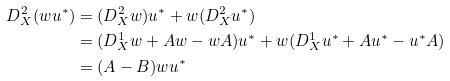Convert formula to latex. <formula><loc_0><loc_0><loc_500><loc_500>D _ { X } ^ { 2 } ( w u ^ { * } ) & = ( D ^ { 2 } _ { X } w ) u ^ { * } + w ( D _ { X } ^ { 2 } u ^ { * } ) \\ & = ( D ^ { 1 } _ { X } w + A w - w A ) u ^ { * } + w ( D ^ { 1 } _ { X } u ^ { * } + A u ^ { * } - u ^ { * } A ) \\ & = ( A - B ) w u ^ { * }</formula> 